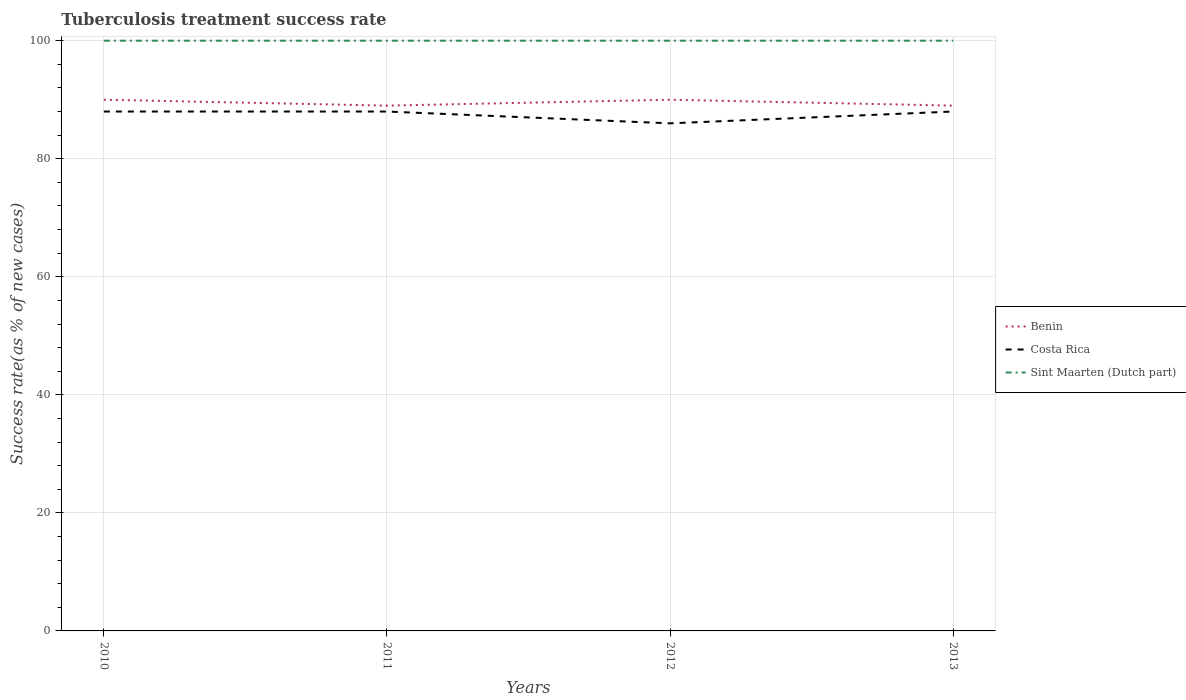How many different coloured lines are there?
Offer a terse response. 3. Across all years, what is the maximum tuberculosis treatment success rate in Benin?
Offer a terse response. 89. In which year was the tuberculosis treatment success rate in Sint Maarten (Dutch part) maximum?
Offer a terse response. 2010. What is the total tuberculosis treatment success rate in Benin in the graph?
Provide a short and direct response. 1. What is the difference between the highest and the second highest tuberculosis treatment success rate in Sint Maarten (Dutch part)?
Offer a terse response. 0. What is the difference between the highest and the lowest tuberculosis treatment success rate in Costa Rica?
Ensure brevity in your answer.  3. How many lines are there?
Keep it short and to the point. 3. What is the difference between two consecutive major ticks on the Y-axis?
Give a very brief answer. 20. Are the values on the major ticks of Y-axis written in scientific E-notation?
Ensure brevity in your answer.  No. Where does the legend appear in the graph?
Your response must be concise. Center right. How are the legend labels stacked?
Provide a succinct answer. Vertical. What is the title of the graph?
Make the answer very short. Tuberculosis treatment success rate. Does "Greenland" appear as one of the legend labels in the graph?
Offer a very short reply. No. What is the label or title of the X-axis?
Give a very brief answer. Years. What is the label or title of the Y-axis?
Keep it short and to the point. Success rate(as % of new cases). What is the Success rate(as % of new cases) of Benin in 2010?
Your response must be concise. 90. What is the Success rate(as % of new cases) of Benin in 2011?
Give a very brief answer. 89. What is the Success rate(as % of new cases) in Sint Maarten (Dutch part) in 2011?
Ensure brevity in your answer.  100. What is the Success rate(as % of new cases) in Benin in 2012?
Give a very brief answer. 90. What is the Success rate(as % of new cases) in Costa Rica in 2012?
Your answer should be very brief. 86. What is the Success rate(as % of new cases) in Benin in 2013?
Provide a short and direct response. 89. What is the Success rate(as % of new cases) in Sint Maarten (Dutch part) in 2013?
Keep it short and to the point. 100. Across all years, what is the maximum Success rate(as % of new cases) in Benin?
Make the answer very short. 90. Across all years, what is the maximum Success rate(as % of new cases) in Sint Maarten (Dutch part)?
Keep it short and to the point. 100. Across all years, what is the minimum Success rate(as % of new cases) in Benin?
Your answer should be compact. 89. Across all years, what is the minimum Success rate(as % of new cases) in Costa Rica?
Your answer should be very brief. 86. What is the total Success rate(as % of new cases) of Benin in the graph?
Offer a very short reply. 358. What is the total Success rate(as % of new cases) of Costa Rica in the graph?
Your answer should be compact. 350. What is the total Success rate(as % of new cases) in Sint Maarten (Dutch part) in the graph?
Your answer should be very brief. 400. What is the difference between the Success rate(as % of new cases) of Benin in 2010 and that in 2011?
Give a very brief answer. 1. What is the difference between the Success rate(as % of new cases) in Costa Rica in 2010 and that in 2011?
Make the answer very short. 0. What is the difference between the Success rate(as % of new cases) in Benin in 2010 and that in 2013?
Provide a short and direct response. 1. What is the difference between the Success rate(as % of new cases) of Costa Rica in 2010 and that in 2013?
Offer a terse response. 0. What is the difference between the Success rate(as % of new cases) in Benin in 2011 and that in 2012?
Your answer should be very brief. -1. What is the difference between the Success rate(as % of new cases) in Costa Rica in 2011 and that in 2012?
Give a very brief answer. 2. What is the difference between the Success rate(as % of new cases) in Costa Rica in 2011 and that in 2013?
Give a very brief answer. 0. What is the difference between the Success rate(as % of new cases) in Benin in 2012 and that in 2013?
Your answer should be very brief. 1. What is the difference between the Success rate(as % of new cases) in Sint Maarten (Dutch part) in 2012 and that in 2013?
Your answer should be compact. 0. What is the difference between the Success rate(as % of new cases) in Benin in 2010 and the Success rate(as % of new cases) in Costa Rica in 2011?
Keep it short and to the point. 2. What is the difference between the Success rate(as % of new cases) of Benin in 2010 and the Success rate(as % of new cases) of Sint Maarten (Dutch part) in 2011?
Make the answer very short. -10. What is the difference between the Success rate(as % of new cases) of Costa Rica in 2010 and the Success rate(as % of new cases) of Sint Maarten (Dutch part) in 2011?
Ensure brevity in your answer.  -12. What is the difference between the Success rate(as % of new cases) in Costa Rica in 2010 and the Success rate(as % of new cases) in Sint Maarten (Dutch part) in 2012?
Offer a very short reply. -12. What is the difference between the Success rate(as % of new cases) of Benin in 2010 and the Success rate(as % of new cases) of Costa Rica in 2013?
Ensure brevity in your answer.  2. What is the difference between the Success rate(as % of new cases) in Benin in 2010 and the Success rate(as % of new cases) in Sint Maarten (Dutch part) in 2013?
Offer a very short reply. -10. What is the difference between the Success rate(as % of new cases) in Benin in 2011 and the Success rate(as % of new cases) in Costa Rica in 2012?
Make the answer very short. 3. What is the difference between the Success rate(as % of new cases) of Costa Rica in 2011 and the Success rate(as % of new cases) of Sint Maarten (Dutch part) in 2012?
Offer a terse response. -12. What is the difference between the Success rate(as % of new cases) of Benin in 2011 and the Success rate(as % of new cases) of Sint Maarten (Dutch part) in 2013?
Offer a very short reply. -11. What is the difference between the Success rate(as % of new cases) of Benin in 2012 and the Success rate(as % of new cases) of Costa Rica in 2013?
Provide a succinct answer. 2. What is the average Success rate(as % of new cases) in Benin per year?
Offer a terse response. 89.5. What is the average Success rate(as % of new cases) of Costa Rica per year?
Your answer should be compact. 87.5. What is the average Success rate(as % of new cases) of Sint Maarten (Dutch part) per year?
Provide a short and direct response. 100. In the year 2010, what is the difference between the Success rate(as % of new cases) in Benin and Success rate(as % of new cases) in Costa Rica?
Offer a terse response. 2. In the year 2010, what is the difference between the Success rate(as % of new cases) of Benin and Success rate(as % of new cases) of Sint Maarten (Dutch part)?
Provide a short and direct response. -10. In the year 2011, what is the difference between the Success rate(as % of new cases) of Benin and Success rate(as % of new cases) of Costa Rica?
Keep it short and to the point. 1. In the year 2011, what is the difference between the Success rate(as % of new cases) in Benin and Success rate(as % of new cases) in Sint Maarten (Dutch part)?
Give a very brief answer. -11. In the year 2012, what is the difference between the Success rate(as % of new cases) in Benin and Success rate(as % of new cases) in Costa Rica?
Provide a short and direct response. 4. In the year 2012, what is the difference between the Success rate(as % of new cases) in Costa Rica and Success rate(as % of new cases) in Sint Maarten (Dutch part)?
Offer a terse response. -14. In the year 2013, what is the difference between the Success rate(as % of new cases) in Benin and Success rate(as % of new cases) in Sint Maarten (Dutch part)?
Offer a very short reply. -11. What is the ratio of the Success rate(as % of new cases) in Benin in 2010 to that in 2011?
Offer a terse response. 1.01. What is the ratio of the Success rate(as % of new cases) of Sint Maarten (Dutch part) in 2010 to that in 2011?
Your answer should be very brief. 1. What is the ratio of the Success rate(as % of new cases) of Costa Rica in 2010 to that in 2012?
Your answer should be very brief. 1.02. What is the ratio of the Success rate(as % of new cases) in Benin in 2010 to that in 2013?
Your answer should be compact. 1.01. What is the ratio of the Success rate(as % of new cases) in Sint Maarten (Dutch part) in 2010 to that in 2013?
Your answer should be compact. 1. What is the ratio of the Success rate(as % of new cases) of Benin in 2011 to that in 2012?
Give a very brief answer. 0.99. What is the ratio of the Success rate(as % of new cases) of Costa Rica in 2011 to that in 2012?
Offer a very short reply. 1.02. What is the ratio of the Success rate(as % of new cases) in Benin in 2011 to that in 2013?
Your response must be concise. 1. What is the ratio of the Success rate(as % of new cases) in Sint Maarten (Dutch part) in 2011 to that in 2013?
Your answer should be very brief. 1. What is the ratio of the Success rate(as % of new cases) in Benin in 2012 to that in 2013?
Offer a very short reply. 1.01. What is the ratio of the Success rate(as % of new cases) in Costa Rica in 2012 to that in 2013?
Your answer should be very brief. 0.98. What is the ratio of the Success rate(as % of new cases) in Sint Maarten (Dutch part) in 2012 to that in 2013?
Make the answer very short. 1. What is the difference between the highest and the second highest Success rate(as % of new cases) in Costa Rica?
Offer a terse response. 0. What is the difference between the highest and the second highest Success rate(as % of new cases) in Sint Maarten (Dutch part)?
Your answer should be compact. 0. What is the difference between the highest and the lowest Success rate(as % of new cases) of Benin?
Provide a short and direct response. 1. What is the difference between the highest and the lowest Success rate(as % of new cases) of Costa Rica?
Ensure brevity in your answer.  2. 